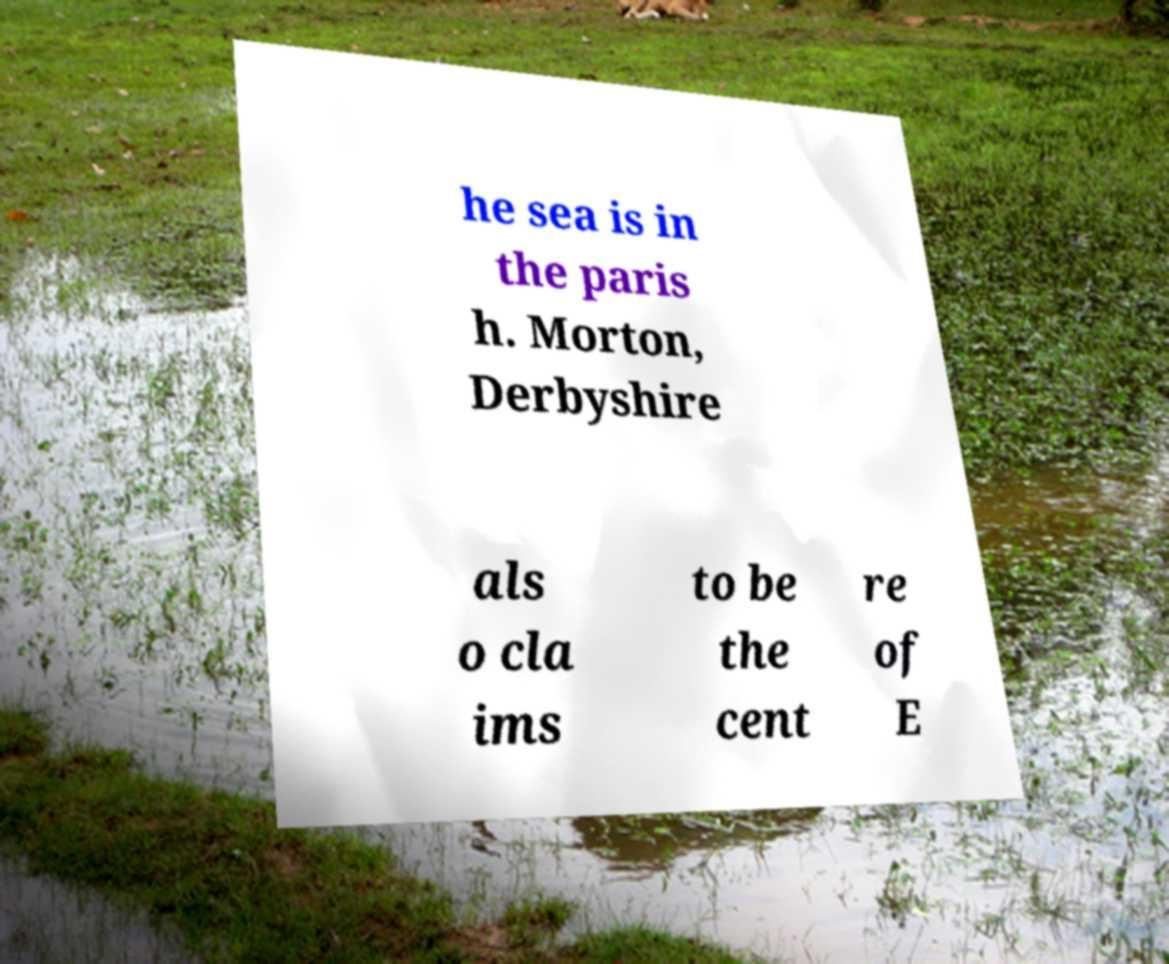Could you assist in decoding the text presented in this image and type it out clearly? he sea is in the paris h. Morton, Derbyshire als o cla ims to be the cent re of E 